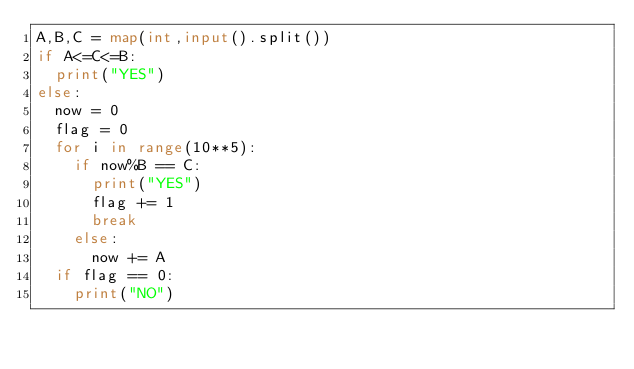Convert code to text. <code><loc_0><loc_0><loc_500><loc_500><_Python_>A,B,C = map(int,input().split())
if A<=C<=B:
  print("YES")
else:
  now = 0
  flag = 0
  for i in range(10**5):
    if now%B == C:
      print("YES")
      flag += 1
      break
    else:
      now += A
  if flag == 0:
    print("NO")</code> 